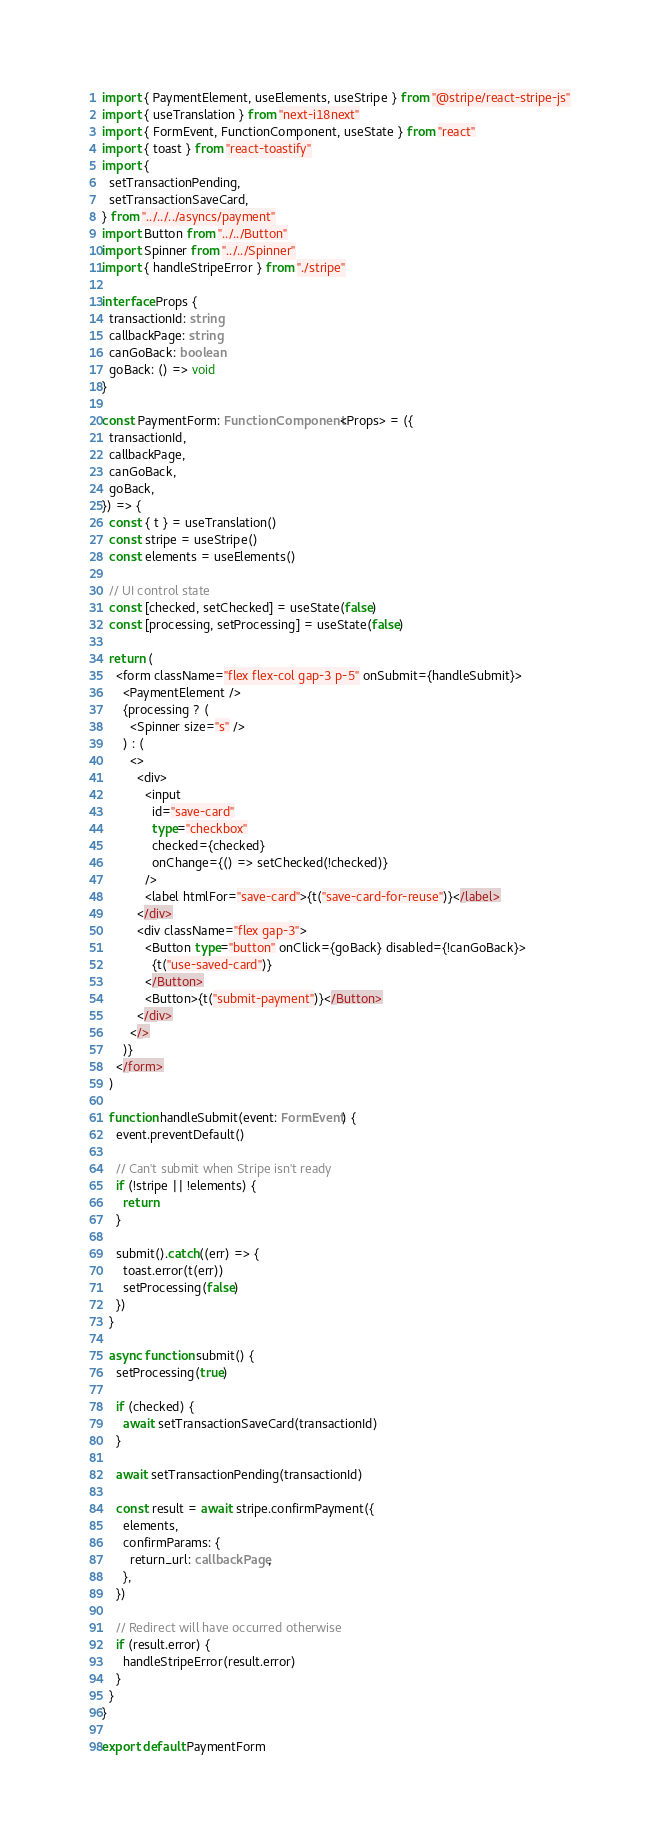<code> <loc_0><loc_0><loc_500><loc_500><_TypeScript_>import { PaymentElement, useElements, useStripe } from "@stripe/react-stripe-js"
import { useTranslation } from "next-i18next"
import { FormEvent, FunctionComponent, useState } from "react"
import { toast } from "react-toastify"
import {
  setTransactionPending,
  setTransactionSaveCard,
} from "../../../asyncs/payment"
import Button from "../../Button"
import Spinner from "../../Spinner"
import { handleStripeError } from "./stripe"

interface Props {
  transactionId: string
  callbackPage: string
  canGoBack: boolean
  goBack: () => void
}

const PaymentForm: FunctionComponent<Props> = ({
  transactionId,
  callbackPage,
  canGoBack,
  goBack,
}) => {
  const { t } = useTranslation()
  const stripe = useStripe()
  const elements = useElements()

  // UI control state
  const [checked, setChecked] = useState(false)
  const [processing, setProcessing] = useState(false)

  return (
    <form className="flex flex-col gap-3 p-5" onSubmit={handleSubmit}>
      <PaymentElement />
      {processing ? (
        <Spinner size="s" />
      ) : (
        <>
          <div>
            <input
              id="save-card"
              type="checkbox"
              checked={checked}
              onChange={() => setChecked(!checked)}
            />
            <label htmlFor="save-card">{t("save-card-for-reuse")}</label>
          </div>
          <div className="flex gap-3">
            <Button type="button" onClick={goBack} disabled={!canGoBack}>
              {t("use-saved-card")}
            </Button>
            <Button>{t("submit-payment")}</Button>
          </div>
        </>
      )}
    </form>
  )

  function handleSubmit(event: FormEvent) {
    event.preventDefault()

    // Can't submit when Stripe isn't ready
    if (!stripe || !elements) {
      return
    }

    submit().catch((err) => {
      toast.error(t(err))
      setProcessing(false)
    })
  }

  async function submit() {
    setProcessing(true)

    if (checked) {
      await setTransactionSaveCard(transactionId)
    }

    await setTransactionPending(transactionId)

    const result = await stripe.confirmPayment({
      elements,
      confirmParams: {
        return_url: callbackPage,
      },
    })

    // Redirect will have occurred otherwise
    if (result.error) {
      handleStripeError(result.error)
    }
  }
}

export default PaymentForm
</code> 